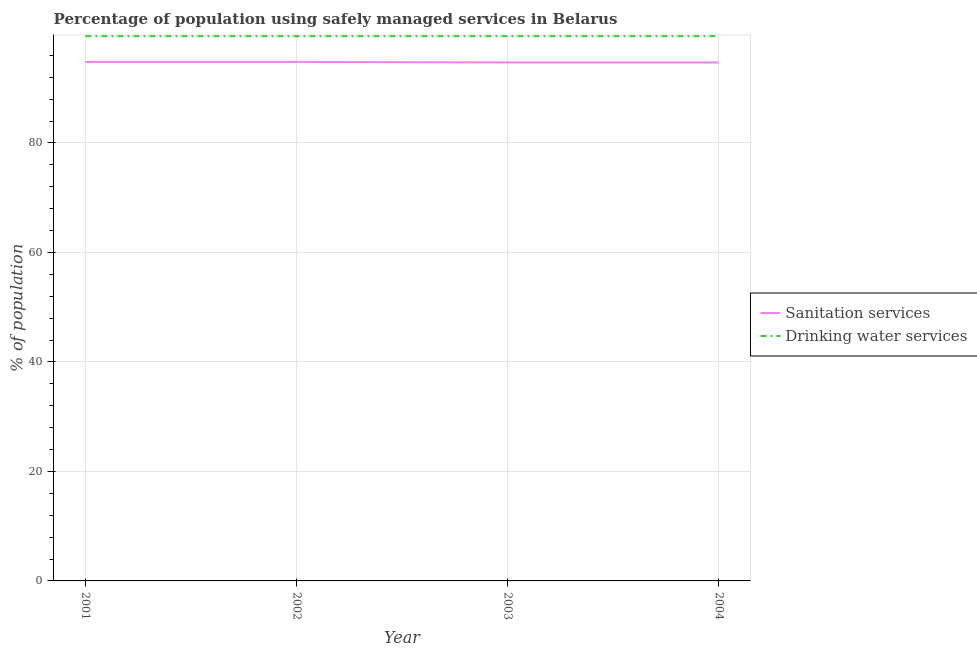How many different coloured lines are there?
Keep it short and to the point. 2. What is the percentage of population who used sanitation services in 2004?
Your answer should be compact. 94.7. Across all years, what is the maximum percentage of population who used sanitation services?
Provide a short and direct response. 94.8. Across all years, what is the minimum percentage of population who used sanitation services?
Offer a very short reply. 94.7. In which year was the percentage of population who used sanitation services maximum?
Offer a very short reply. 2001. In which year was the percentage of population who used sanitation services minimum?
Provide a succinct answer. 2003. What is the total percentage of population who used drinking water services in the graph?
Provide a succinct answer. 398. What is the difference between the percentage of population who used sanitation services in 2003 and the percentage of population who used drinking water services in 2001?
Offer a terse response. -4.8. What is the average percentage of population who used sanitation services per year?
Your answer should be compact. 94.75. In the year 2003, what is the difference between the percentage of population who used sanitation services and percentage of population who used drinking water services?
Ensure brevity in your answer.  -4.8. In how many years, is the percentage of population who used sanitation services greater than 44 %?
Give a very brief answer. 4. What is the ratio of the percentage of population who used drinking water services in 2001 to that in 2003?
Your answer should be very brief. 1. Is the percentage of population who used sanitation services in 2003 less than that in 2004?
Provide a succinct answer. No. Is the difference between the percentage of population who used drinking water services in 2003 and 2004 greater than the difference between the percentage of population who used sanitation services in 2003 and 2004?
Offer a terse response. No. What is the difference between the highest and the lowest percentage of population who used drinking water services?
Offer a very short reply. 0. Is the sum of the percentage of population who used drinking water services in 2002 and 2003 greater than the maximum percentage of population who used sanitation services across all years?
Provide a short and direct response. Yes. Does the percentage of population who used sanitation services monotonically increase over the years?
Keep it short and to the point. No. Is the percentage of population who used drinking water services strictly less than the percentage of population who used sanitation services over the years?
Offer a very short reply. No. What is the difference between two consecutive major ticks on the Y-axis?
Offer a terse response. 20. Does the graph contain grids?
Your response must be concise. Yes. Where does the legend appear in the graph?
Offer a terse response. Center right. What is the title of the graph?
Ensure brevity in your answer.  Percentage of population using safely managed services in Belarus. Does "Urban" appear as one of the legend labels in the graph?
Give a very brief answer. No. What is the label or title of the X-axis?
Give a very brief answer. Year. What is the label or title of the Y-axis?
Keep it short and to the point. % of population. What is the % of population in Sanitation services in 2001?
Keep it short and to the point. 94.8. What is the % of population of Drinking water services in 2001?
Keep it short and to the point. 99.5. What is the % of population of Sanitation services in 2002?
Make the answer very short. 94.8. What is the % of population in Drinking water services in 2002?
Your answer should be compact. 99.5. What is the % of population of Sanitation services in 2003?
Offer a very short reply. 94.7. What is the % of population in Drinking water services in 2003?
Provide a short and direct response. 99.5. What is the % of population in Sanitation services in 2004?
Your answer should be compact. 94.7. What is the % of population of Drinking water services in 2004?
Ensure brevity in your answer.  99.5. Across all years, what is the maximum % of population of Sanitation services?
Ensure brevity in your answer.  94.8. Across all years, what is the maximum % of population in Drinking water services?
Offer a very short reply. 99.5. Across all years, what is the minimum % of population in Sanitation services?
Ensure brevity in your answer.  94.7. Across all years, what is the minimum % of population of Drinking water services?
Provide a succinct answer. 99.5. What is the total % of population in Sanitation services in the graph?
Your answer should be very brief. 379. What is the total % of population in Drinking water services in the graph?
Your answer should be very brief. 398. What is the difference between the % of population in Sanitation services in 2001 and that in 2003?
Give a very brief answer. 0.1. What is the difference between the % of population in Sanitation services in 2001 and that in 2004?
Provide a succinct answer. 0.1. What is the difference between the % of population in Sanitation services in 2002 and that in 2003?
Ensure brevity in your answer.  0.1. What is the difference between the % of population in Drinking water services in 2002 and that in 2003?
Your response must be concise. 0. What is the difference between the % of population of Sanitation services in 2003 and that in 2004?
Provide a succinct answer. 0. What is the difference between the % of population of Sanitation services in 2001 and the % of population of Drinking water services in 2002?
Provide a short and direct response. -4.7. What is the difference between the % of population of Sanitation services in 2002 and the % of population of Drinking water services in 2004?
Make the answer very short. -4.7. What is the difference between the % of population of Sanitation services in 2003 and the % of population of Drinking water services in 2004?
Offer a terse response. -4.8. What is the average % of population of Sanitation services per year?
Ensure brevity in your answer.  94.75. What is the average % of population in Drinking water services per year?
Your answer should be very brief. 99.5. In the year 2002, what is the difference between the % of population in Sanitation services and % of population in Drinking water services?
Give a very brief answer. -4.7. In the year 2003, what is the difference between the % of population of Sanitation services and % of population of Drinking water services?
Ensure brevity in your answer.  -4.8. What is the ratio of the % of population in Sanitation services in 2001 to that in 2002?
Your answer should be compact. 1. What is the ratio of the % of population of Drinking water services in 2001 to that in 2002?
Your answer should be very brief. 1. What is the ratio of the % of population in Sanitation services in 2001 to that in 2003?
Keep it short and to the point. 1. What is the ratio of the % of population of Drinking water services in 2002 to that in 2004?
Provide a short and direct response. 1. What is the difference between the highest and the second highest % of population of Drinking water services?
Keep it short and to the point. 0. What is the difference between the highest and the lowest % of population of Drinking water services?
Keep it short and to the point. 0. 